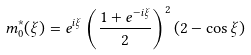Convert formula to latex. <formula><loc_0><loc_0><loc_500><loc_500>m ^ { * } _ { 0 } ( \xi ) = e ^ { i \xi } \left ( \frac { 1 + e ^ { - i \xi } } { 2 } \right ) ^ { 2 } ( 2 - \cos \xi )</formula> 